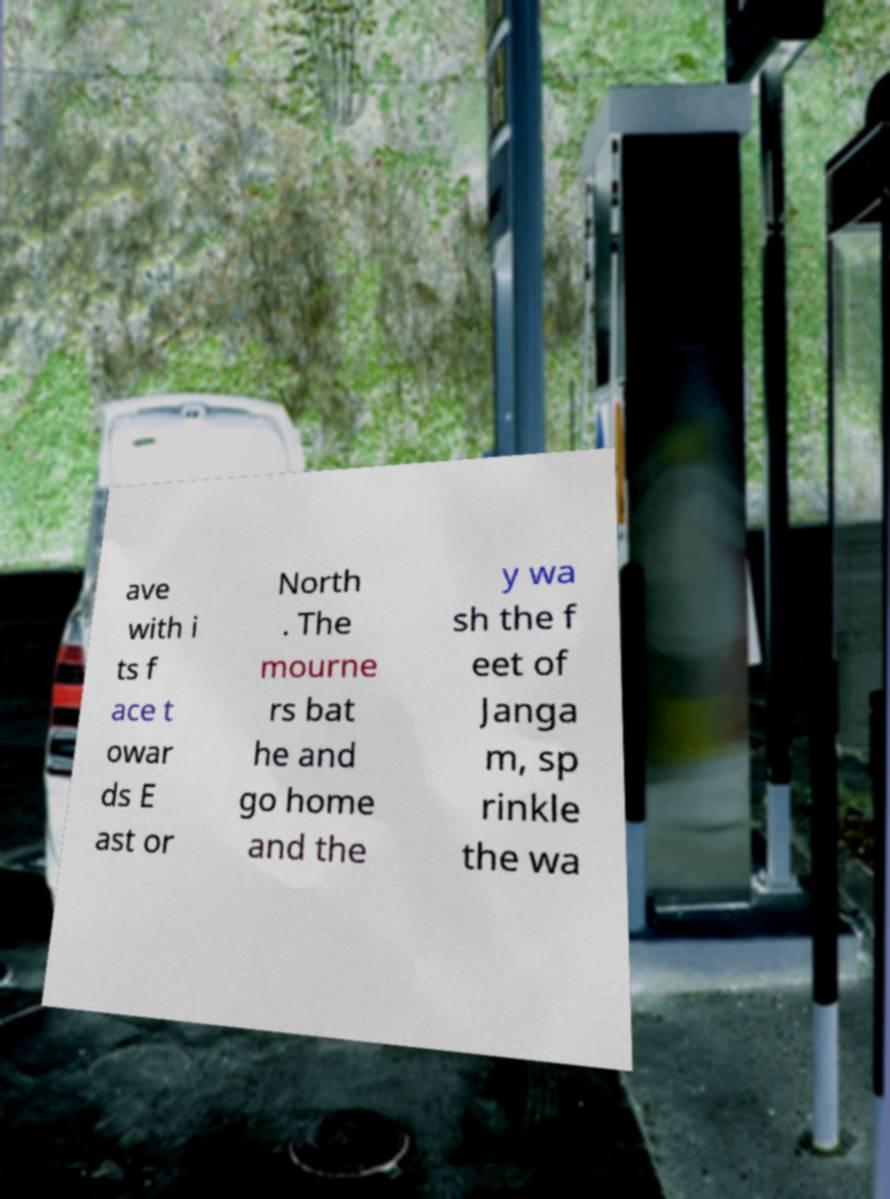Please identify and transcribe the text found in this image. ave with i ts f ace t owar ds E ast or North . The mourne rs bat he and go home and the y wa sh the f eet of Janga m, sp rinkle the wa 